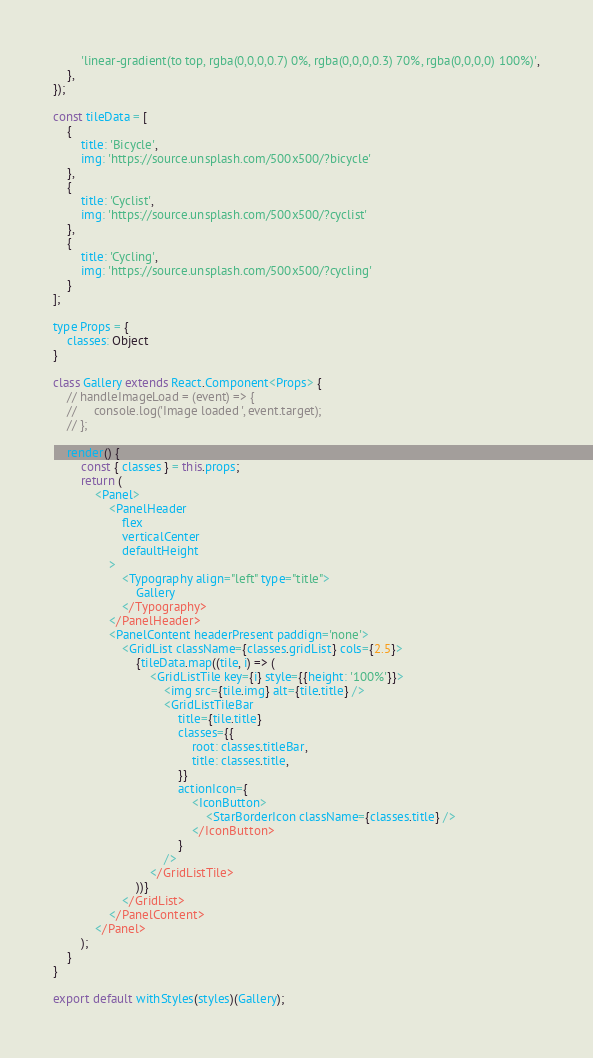<code> <loc_0><loc_0><loc_500><loc_500><_JavaScript_>        'linear-gradient(to top, rgba(0,0,0,0.7) 0%, rgba(0,0,0,0.3) 70%, rgba(0,0,0,0) 100%)',
    },
});

const tileData = [
    {
        title: 'Bicycle',
        img: 'https://source.unsplash.com/500x500/?bicycle'
    },
    {
        title: 'Cyclist',
        img: 'https://source.unsplash.com/500x500/?cyclist'
    },
    {
        title: 'Cycling',
        img: 'https://source.unsplash.com/500x500/?cycling'
    }
];

type Props = {
    classes: Object
}

class Gallery extends React.Component<Props> {
    // handleImageLoad = (event) => {
    //     console.log('Image loaded ', event.target);
    // };

    render() {
        const { classes } = this.props;
        return (
            <Panel>
                <PanelHeader
                    flex
                    verticalCenter
                    defaultHeight
                >
                    <Typography align="left" type="title">
                        Gallery
                    </Typography>
                </PanelHeader>
                <PanelContent headerPresent paddign='none'>
                    <GridList className={classes.gridList} cols={2.5}>
                        {tileData.map((tile, i) => (
                            <GridListTile key={i} style={{height: '100%'}}>
                                <img src={tile.img} alt={tile.title} />
                                <GridListTileBar
                                    title={tile.title}
                                    classes={{
                                        root: classes.titleBar,
                                        title: classes.title,
                                    }}
                                    actionIcon={
                                        <IconButton>
                                            <StarBorderIcon className={classes.title} />
                                        </IconButton>
                                    }
                                />
                            </GridListTile>
                        ))}
                    </GridList>
                </PanelContent>
            </Panel>
        );
    }
}

export default withStyles(styles)(Gallery);
</code> 